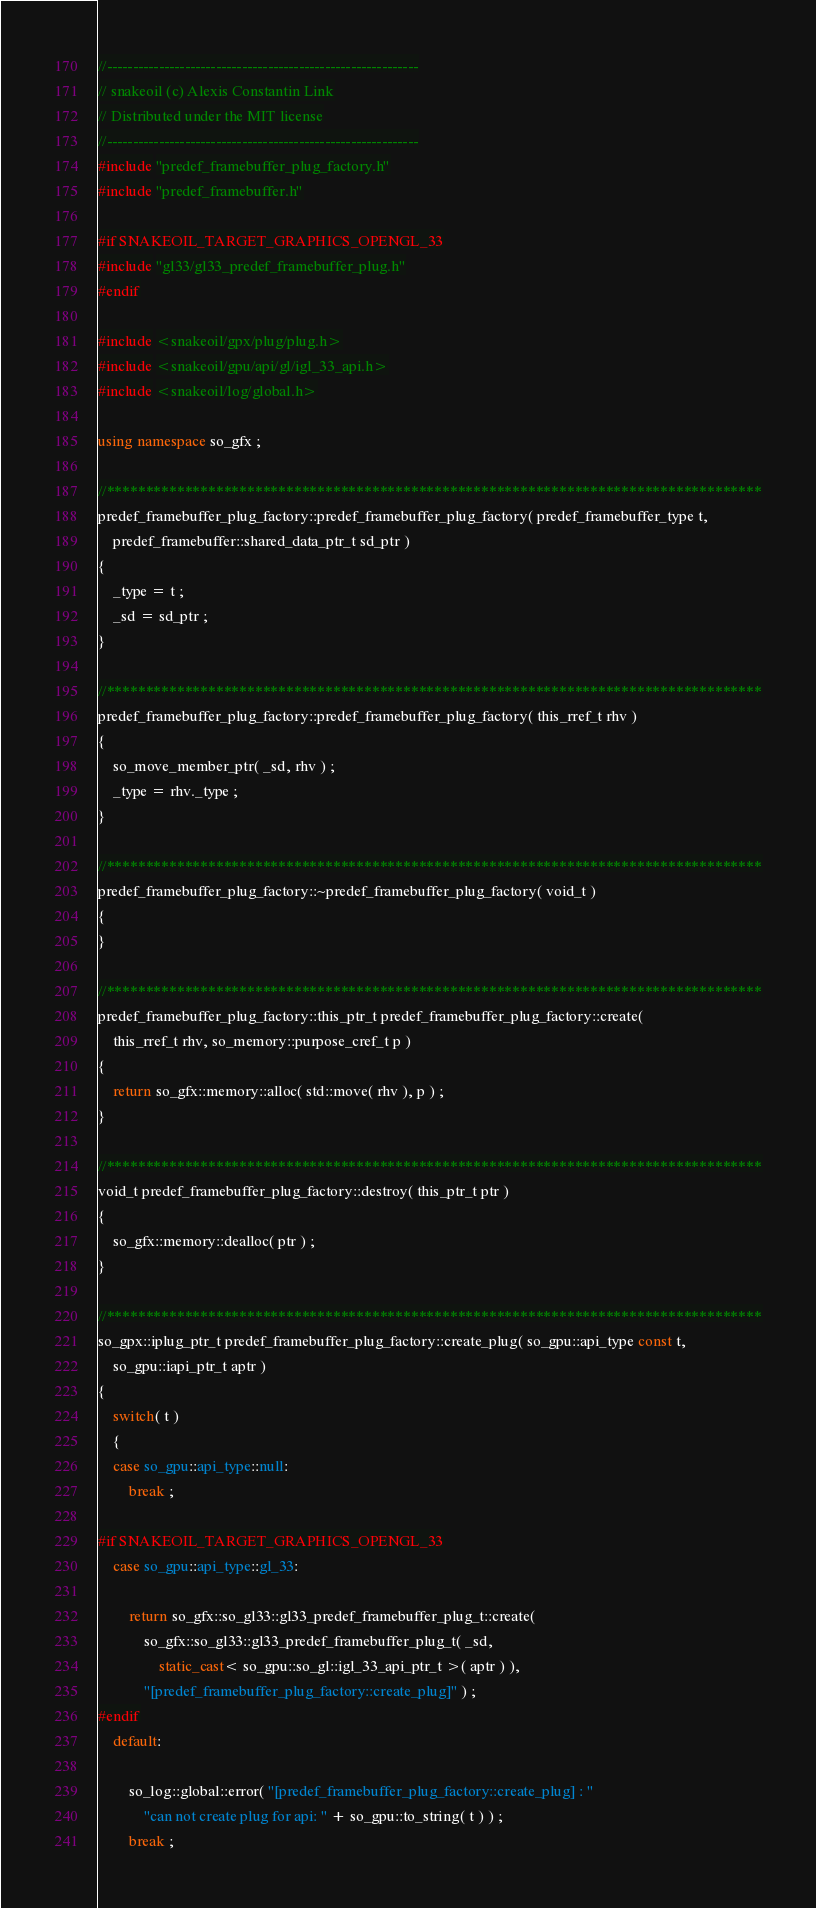<code> <loc_0><loc_0><loc_500><loc_500><_C++_>//------------------------------------------------------------
// snakeoil (c) Alexis Constantin Link
// Distributed under the MIT license
//------------------------------------------------------------
#include "predef_framebuffer_plug_factory.h"
#include "predef_framebuffer.h"

#if SNAKEOIL_TARGET_GRAPHICS_OPENGL_33
#include "gl33/gl33_predef_framebuffer_plug.h"
#endif

#include <snakeoil/gpx/plug/plug.h>
#include <snakeoil/gpu/api/gl/igl_33_api.h>
#include <snakeoil/log/global.h>

using namespace so_gfx ;

//************************************************************************************
predef_framebuffer_plug_factory::predef_framebuffer_plug_factory( predef_framebuffer_type t,
    predef_framebuffer::shared_data_ptr_t sd_ptr )
{
    _type = t ;
    _sd = sd_ptr ;
}

//************************************************************************************
predef_framebuffer_plug_factory::predef_framebuffer_plug_factory( this_rref_t rhv )
{
    so_move_member_ptr( _sd, rhv ) ;
    _type = rhv._type ;
}

//************************************************************************************
predef_framebuffer_plug_factory::~predef_framebuffer_plug_factory( void_t )
{
}

//************************************************************************************
predef_framebuffer_plug_factory::this_ptr_t predef_framebuffer_plug_factory::create(
    this_rref_t rhv, so_memory::purpose_cref_t p )
{
    return so_gfx::memory::alloc( std::move( rhv ), p ) ;
}

//************************************************************************************
void_t predef_framebuffer_plug_factory::destroy( this_ptr_t ptr )
{
    so_gfx::memory::dealloc( ptr ) ;
}

//************************************************************************************
so_gpx::iplug_ptr_t predef_framebuffer_plug_factory::create_plug( so_gpu::api_type const t,
    so_gpu::iapi_ptr_t aptr )
{
    switch( t )
    {
    case so_gpu::api_type::null:
        break ;

#if SNAKEOIL_TARGET_GRAPHICS_OPENGL_33
    case so_gpu::api_type::gl_33:

        return so_gfx::so_gl33::gl33_predef_framebuffer_plug_t::create(
            so_gfx::so_gl33::gl33_predef_framebuffer_plug_t( _sd,
                static_cast< so_gpu::so_gl::igl_33_api_ptr_t >( aptr ) ),
            "[predef_framebuffer_plug_factory::create_plug]" ) ;
#endif
    default:

        so_log::global::error( "[predef_framebuffer_plug_factory::create_plug] : "
            "can not create plug for api: " + so_gpu::to_string( t ) ) ;
        break ;</code> 